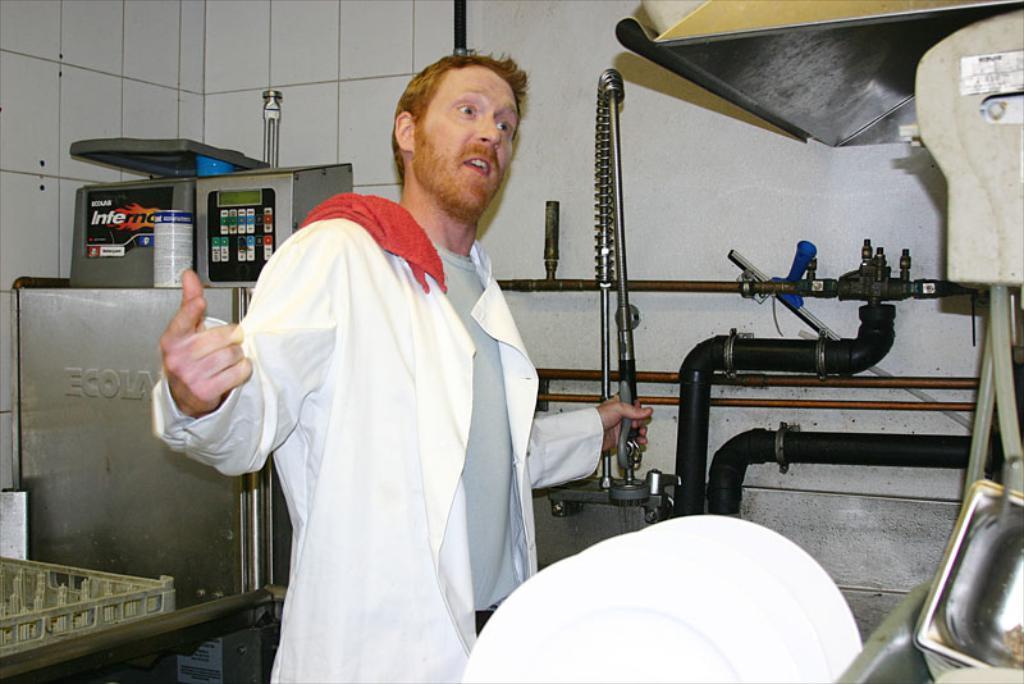Could you give a brief overview of what you see in this image? In the picture there is a man standing and holding an object with the hand, there are machines present, there is a wall. 